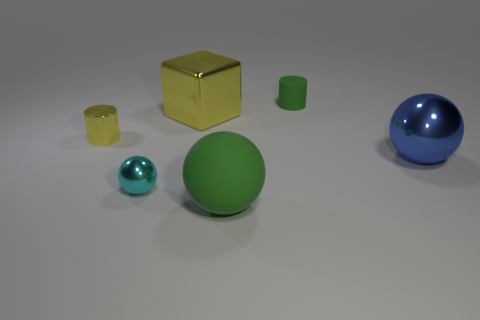There is a rubber thing that is to the right of the green sphere; does it have the same color as the large matte thing? The rubber object to the right of the green sphere shares a similar yellow hue with the matte cube, although the cube's color may appear slightly darker due to its material and surface properties. 